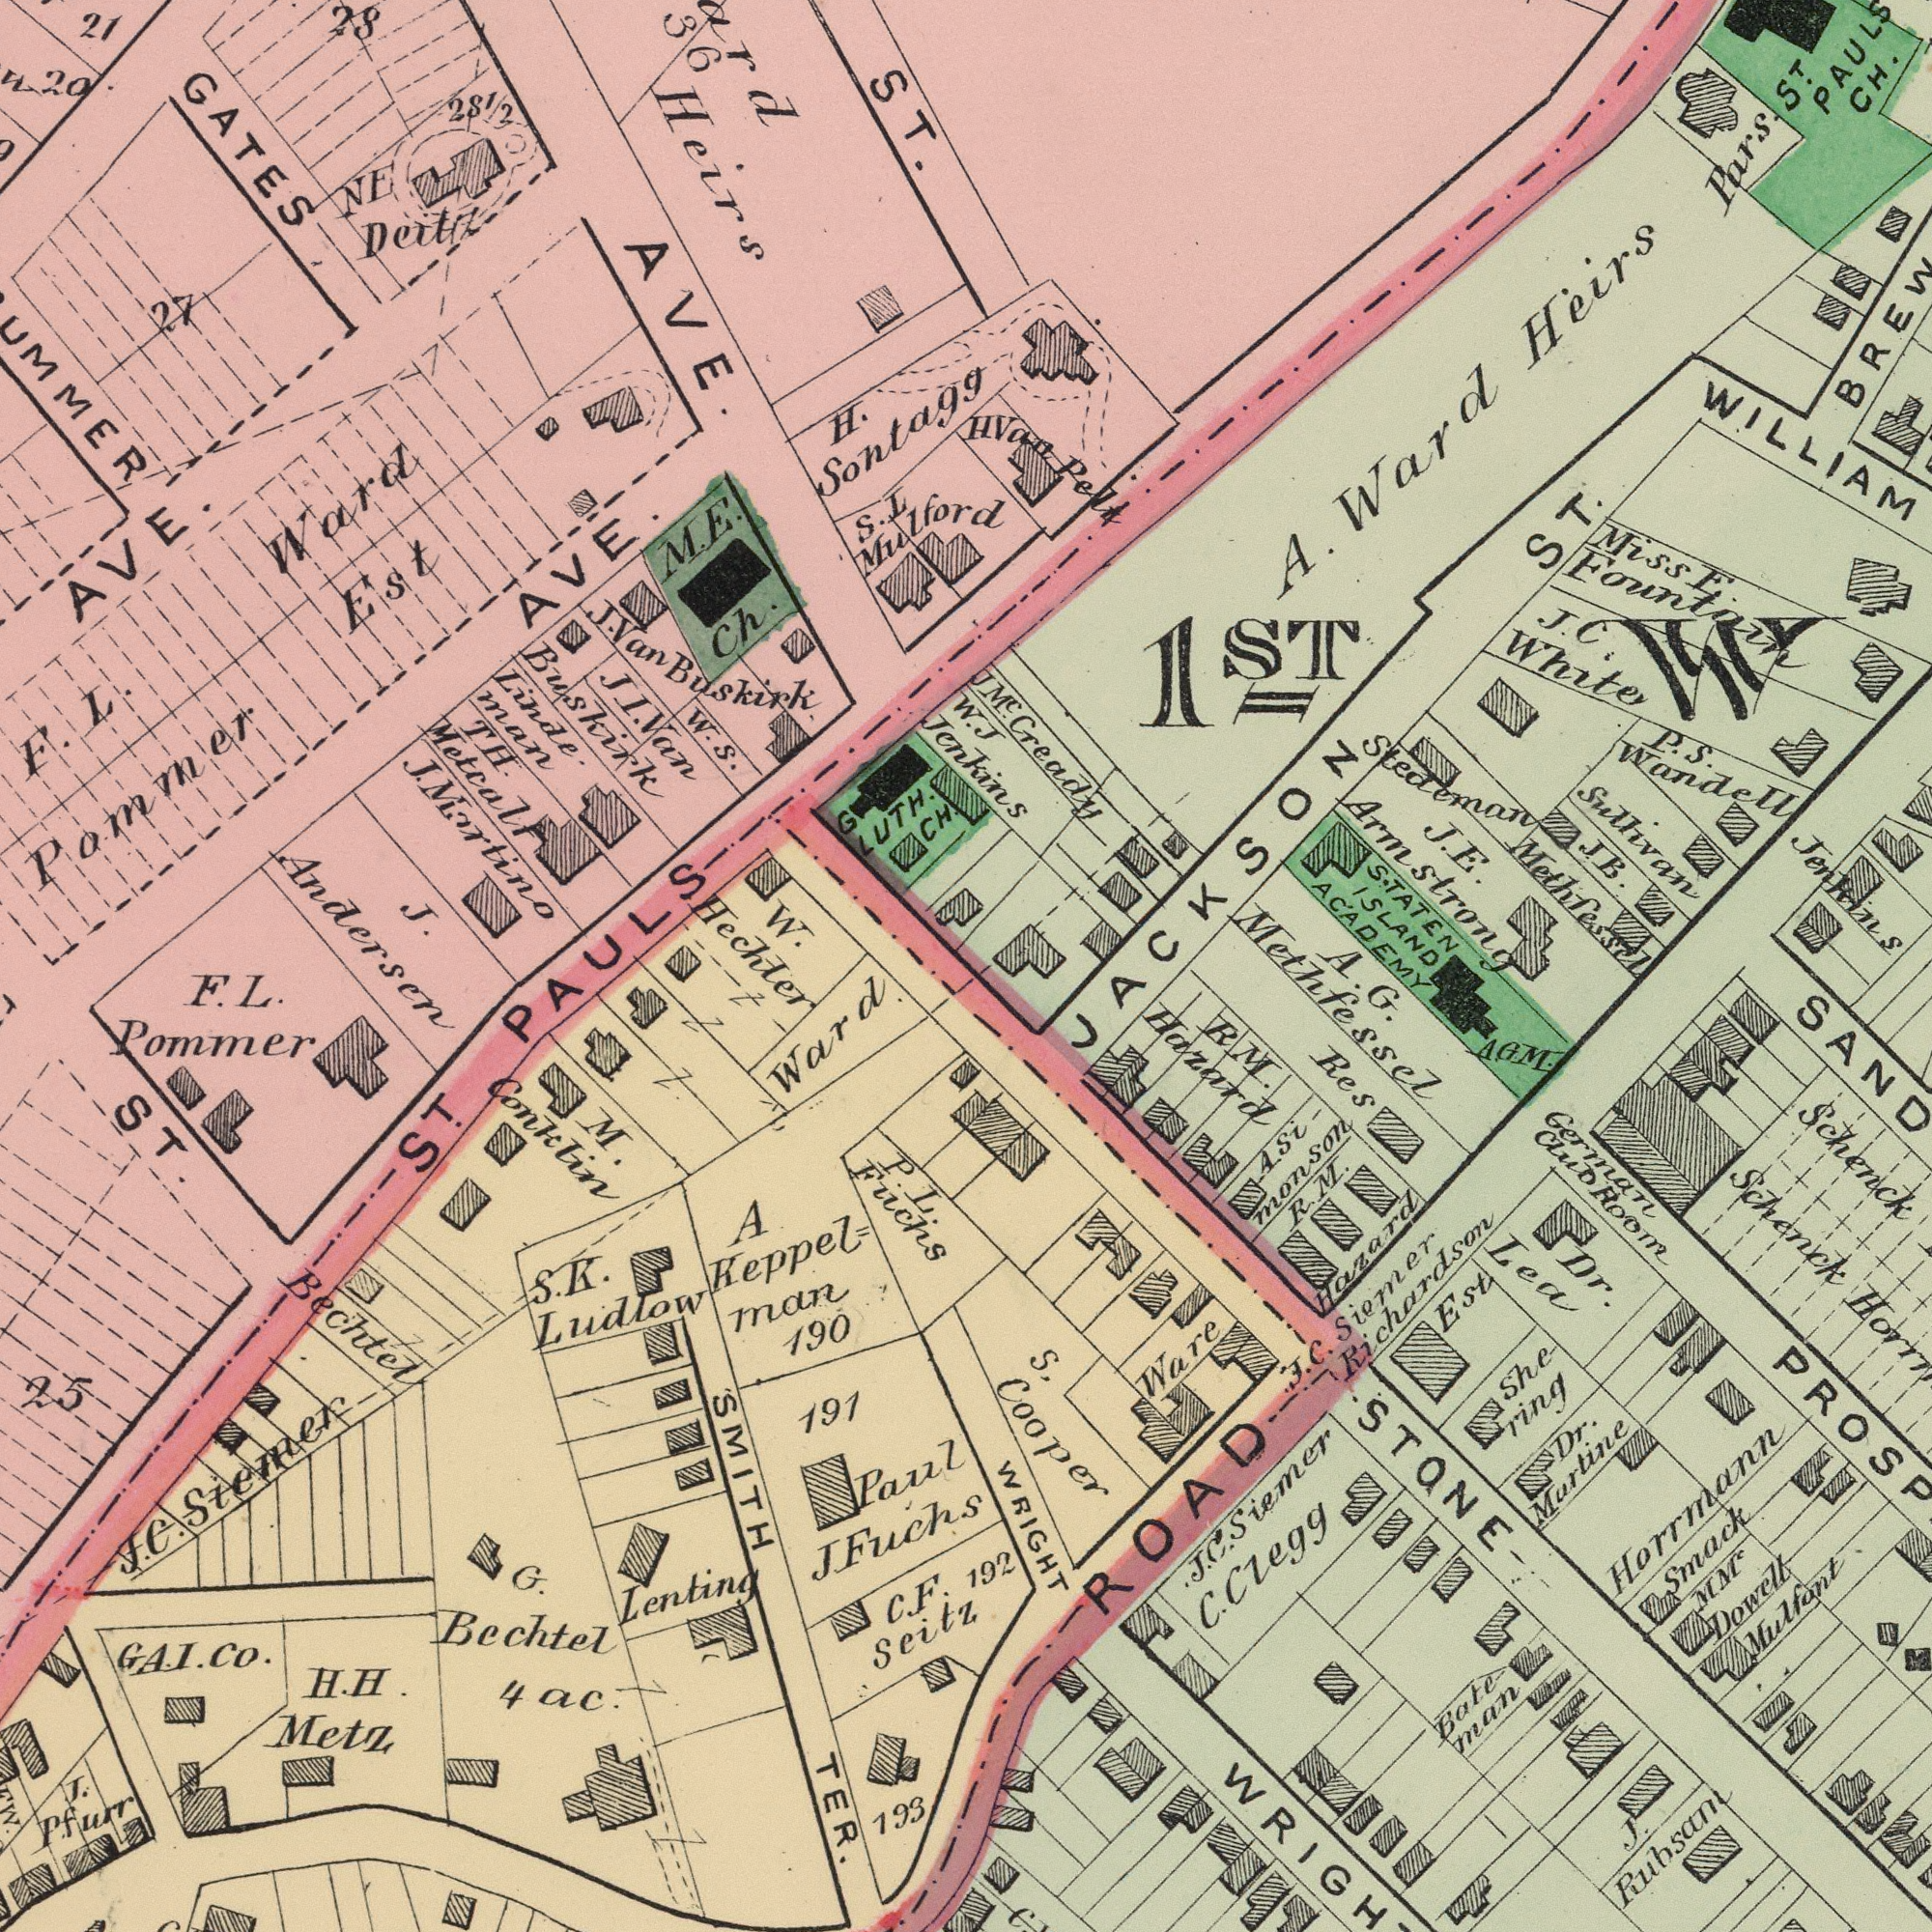What text is visible in the lower-right corner? A. G. Methfessel German Club Room WRIGHT R M. Hazard C. Clegg Ware Mulfont S, Cooper Horrmann Schenck M.MC Dowell J. C. Siemer Richardson Est Res J. Rubsam Asi- monson Bate man Schenck 192 J. C. Siemer She- ring Smack R. M. Hazard Dr. Lea Dr. Murtine ROAD STONE A. G. M. What text can you see in the bottom-left section? Bechtel P. L. Fuchs A. Keppel= man SMITH TER. H. H. Metz 191 J. C. Siemer Lenting F. L. Pommer M. Conklin C. F. Seitz Ward S. K. Ludlow GA. I. Co. J. P. furr Paul J. Fuchs 193 G. Bechtel ST 190 4ac. ST. 25 What text appears in the top-left area of the image? GATES J. Van Buskirk H. Sontagg TH. Metcalf JI. Van Buskirk Linde man J. Andersen 21 AVE. M. E. Ch. S. L Mulford J. Mortino NE Deitz Ward Est 281/2 W. Hechter 28 Heirs AVE. AVE. G LUTH. CH. F. L. Pammer 27 20 W. S. ST. 36 W. PAULS What text appears in the top-right area of the image? WILLIAM Sulhvan J. C. White J. E. Armstrong Stedeman A. Ward Heirs Pars. STATEN ISLAND ACADEMY JM.C Gready Jenkins J. Jenkins ST CH. 1ST J. B. Miss E. Fountain H Van Pelt P. S. Wandell Methfessel JACKSON ST. 